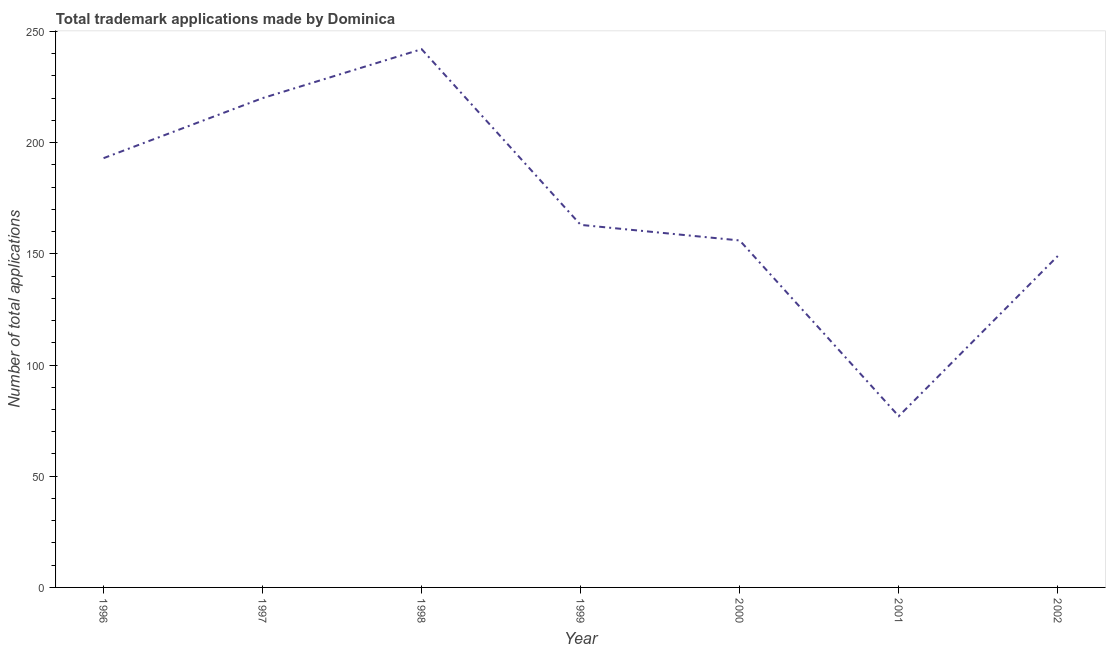What is the number of trademark applications in 2001?
Give a very brief answer. 77. Across all years, what is the maximum number of trademark applications?
Give a very brief answer. 242. Across all years, what is the minimum number of trademark applications?
Your answer should be very brief. 77. In which year was the number of trademark applications maximum?
Offer a terse response. 1998. In which year was the number of trademark applications minimum?
Ensure brevity in your answer.  2001. What is the sum of the number of trademark applications?
Keep it short and to the point. 1200. What is the difference between the number of trademark applications in 1996 and 1998?
Your answer should be compact. -49. What is the average number of trademark applications per year?
Ensure brevity in your answer.  171.43. What is the median number of trademark applications?
Ensure brevity in your answer.  163. What is the ratio of the number of trademark applications in 1998 to that in 2000?
Keep it short and to the point. 1.55. Is the number of trademark applications in 1997 less than that in 2002?
Make the answer very short. No. What is the difference between the highest and the lowest number of trademark applications?
Give a very brief answer. 165. In how many years, is the number of trademark applications greater than the average number of trademark applications taken over all years?
Provide a short and direct response. 3. What is the difference between two consecutive major ticks on the Y-axis?
Your answer should be compact. 50. Are the values on the major ticks of Y-axis written in scientific E-notation?
Your answer should be compact. No. Does the graph contain any zero values?
Your response must be concise. No. Does the graph contain grids?
Give a very brief answer. No. What is the title of the graph?
Give a very brief answer. Total trademark applications made by Dominica. What is the label or title of the Y-axis?
Keep it short and to the point. Number of total applications. What is the Number of total applications of 1996?
Make the answer very short. 193. What is the Number of total applications in 1997?
Offer a very short reply. 220. What is the Number of total applications in 1998?
Ensure brevity in your answer.  242. What is the Number of total applications in 1999?
Offer a terse response. 163. What is the Number of total applications in 2000?
Offer a very short reply. 156. What is the Number of total applications of 2002?
Keep it short and to the point. 149. What is the difference between the Number of total applications in 1996 and 1997?
Keep it short and to the point. -27. What is the difference between the Number of total applications in 1996 and 1998?
Provide a succinct answer. -49. What is the difference between the Number of total applications in 1996 and 2000?
Keep it short and to the point. 37. What is the difference between the Number of total applications in 1996 and 2001?
Your answer should be very brief. 116. What is the difference between the Number of total applications in 1997 and 1999?
Your answer should be compact. 57. What is the difference between the Number of total applications in 1997 and 2001?
Offer a very short reply. 143. What is the difference between the Number of total applications in 1997 and 2002?
Provide a short and direct response. 71. What is the difference between the Number of total applications in 1998 and 1999?
Offer a terse response. 79. What is the difference between the Number of total applications in 1998 and 2001?
Provide a succinct answer. 165. What is the difference between the Number of total applications in 1998 and 2002?
Provide a succinct answer. 93. What is the difference between the Number of total applications in 1999 and 2000?
Offer a terse response. 7. What is the difference between the Number of total applications in 1999 and 2001?
Make the answer very short. 86. What is the difference between the Number of total applications in 2000 and 2001?
Your answer should be compact. 79. What is the difference between the Number of total applications in 2000 and 2002?
Provide a short and direct response. 7. What is the difference between the Number of total applications in 2001 and 2002?
Ensure brevity in your answer.  -72. What is the ratio of the Number of total applications in 1996 to that in 1997?
Provide a succinct answer. 0.88. What is the ratio of the Number of total applications in 1996 to that in 1998?
Your answer should be compact. 0.8. What is the ratio of the Number of total applications in 1996 to that in 1999?
Your answer should be very brief. 1.18. What is the ratio of the Number of total applications in 1996 to that in 2000?
Ensure brevity in your answer.  1.24. What is the ratio of the Number of total applications in 1996 to that in 2001?
Your answer should be compact. 2.51. What is the ratio of the Number of total applications in 1996 to that in 2002?
Ensure brevity in your answer.  1.29. What is the ratio of the Number of total applications in 1997 to that in 1998?
Provide a succinct answer. 0.91. What is the ratio of the Number of total applications in 1997 to that in 1999?
Give a very brief answer. 1.35. What is the ratio of the Number of total applications in 1997 to that in 2000?
Your answer should be very brief. 1.41. What is the ratio of the Number of total applications in 1997 to that in 2001?
Offer a terse response. 2.86. What is the ratio of the Number of total applications in 1997 to that in 2002?
Offer a terse response. 1.48. What is the ratio of the Number of total applications in 1998 to that in 1999?
Offer a terse response. 1.49. What is the ratio of the Number of total applications in 1998 to that in 2000?
Provide a short and direct response. 1.55. What is the ratio of the Number of total applications in 1998 to that in 2001?
Offer a very short reply. 3.14. What is the ratio of the Number of total applications in 1998 to that in 2002?
Your response must be concise. 1.62. What is the ratio of the Number of total applications in 1999 to that in 2000?
Make the answer very short. 1.04. What is the ratio of the Number of total applications in 1999 to that in 2001?
Your answer should be compact. 2.12. What is the ratio of the Number of total applications in 1999 to that in 2002?
Provide a short and direct response. 1.09. What is the ratio of the Number of total applications in 2000 to that in 2001?
Make the answer very short. 2.03. What is the ratio of the Number of total applications in 2000 to that in 2002?
Offer a terse response. 1.05. What is the ratio of the Number of total applications in 2001 to that in 2002?
Ensure brevity in your answer.  0.52. 